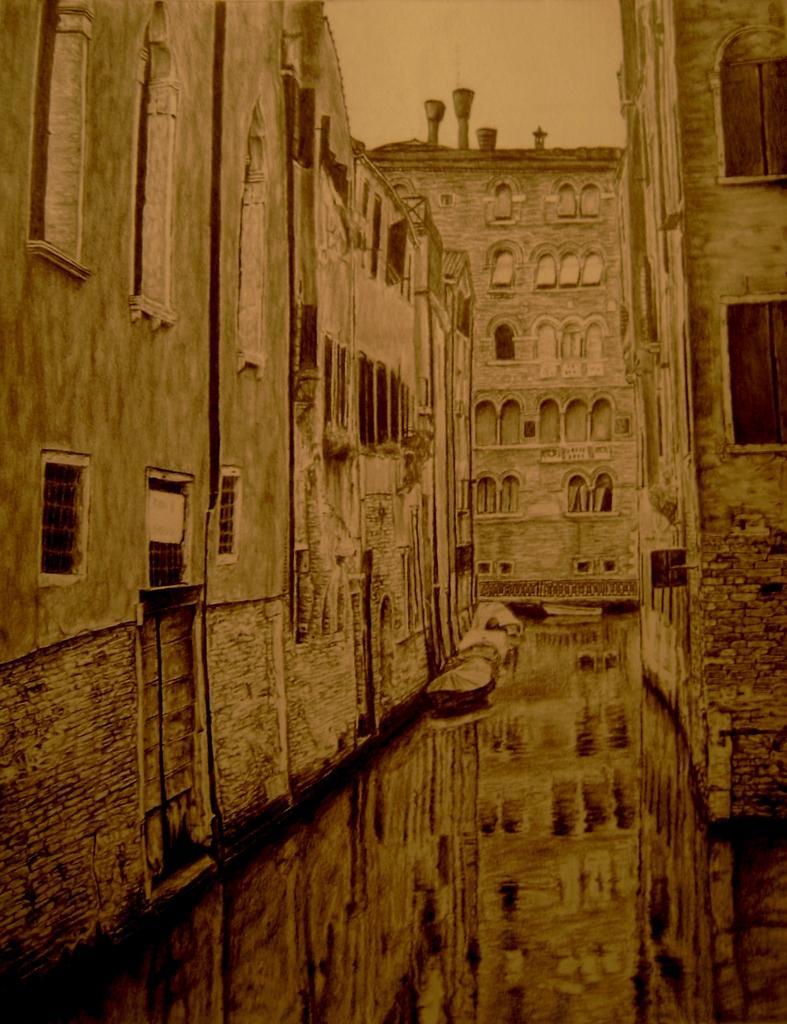Describe this image in one or two sentences. In this edited image there are buildings. There are windows, doors and ventilators to the buildings. At the top there is the sky. At the bottom there is water on the ground. 